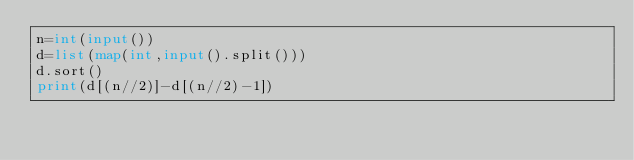<code> <loc_0><loc_0><loc_500><loc_500><_Python_>n=int(input())
d=list(map(int,input().split()))
d.sort()
print(d[(n//2)]-d[(n//2)-1])</code> 